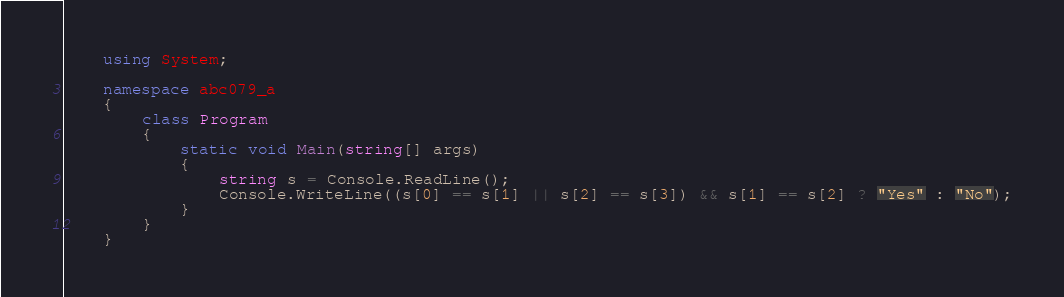Convert code to text. <code><loc_0><loc_0><loc_500><loc_500><_C#_>    using System;
     
    namespace abc079_a
    {
        class Program
        {
            static void Main(string[] args)
            {
                string s = Console.ReadLine();
                Console.WriteLine((s[0] == s[1] || s[2] == s[3]) && s[1] == s[2] ? "Yes" : "No");
            }
        }
    }</code> 